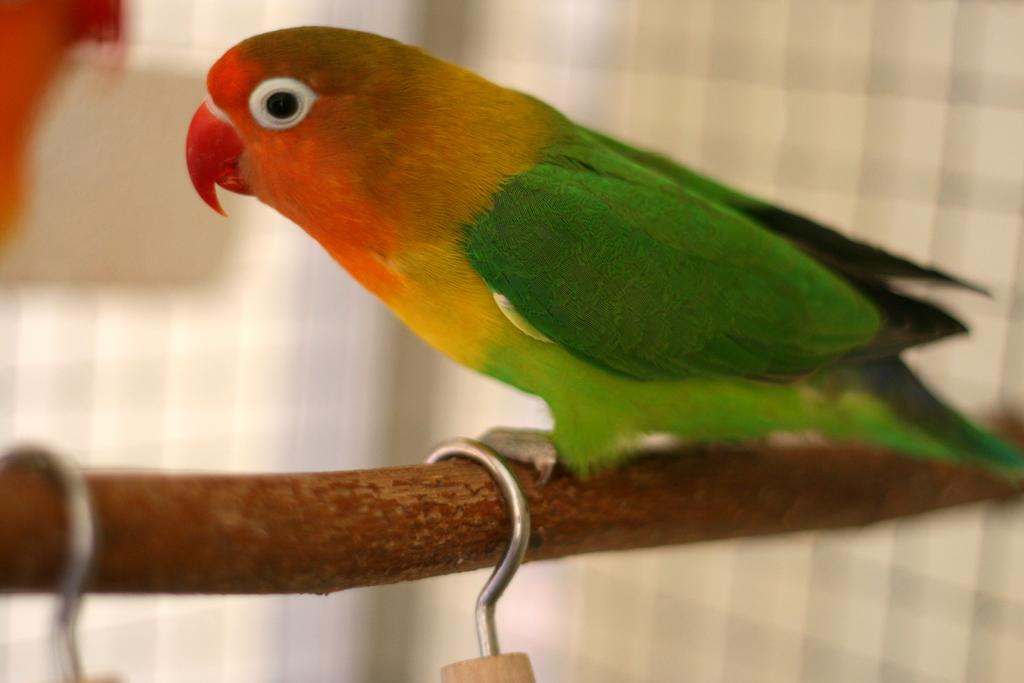What type of animal is in the image? There is a parrot in the image. Where is the parrot located? The parrot is on a small wooden log. What else can be seen in the image besides the parrot? There are hooks visible in the image. What type of shirt is the parrot wearing in the image? The parrot is not wearing a shirt in the image; it is a bird and does not wear clothing. 